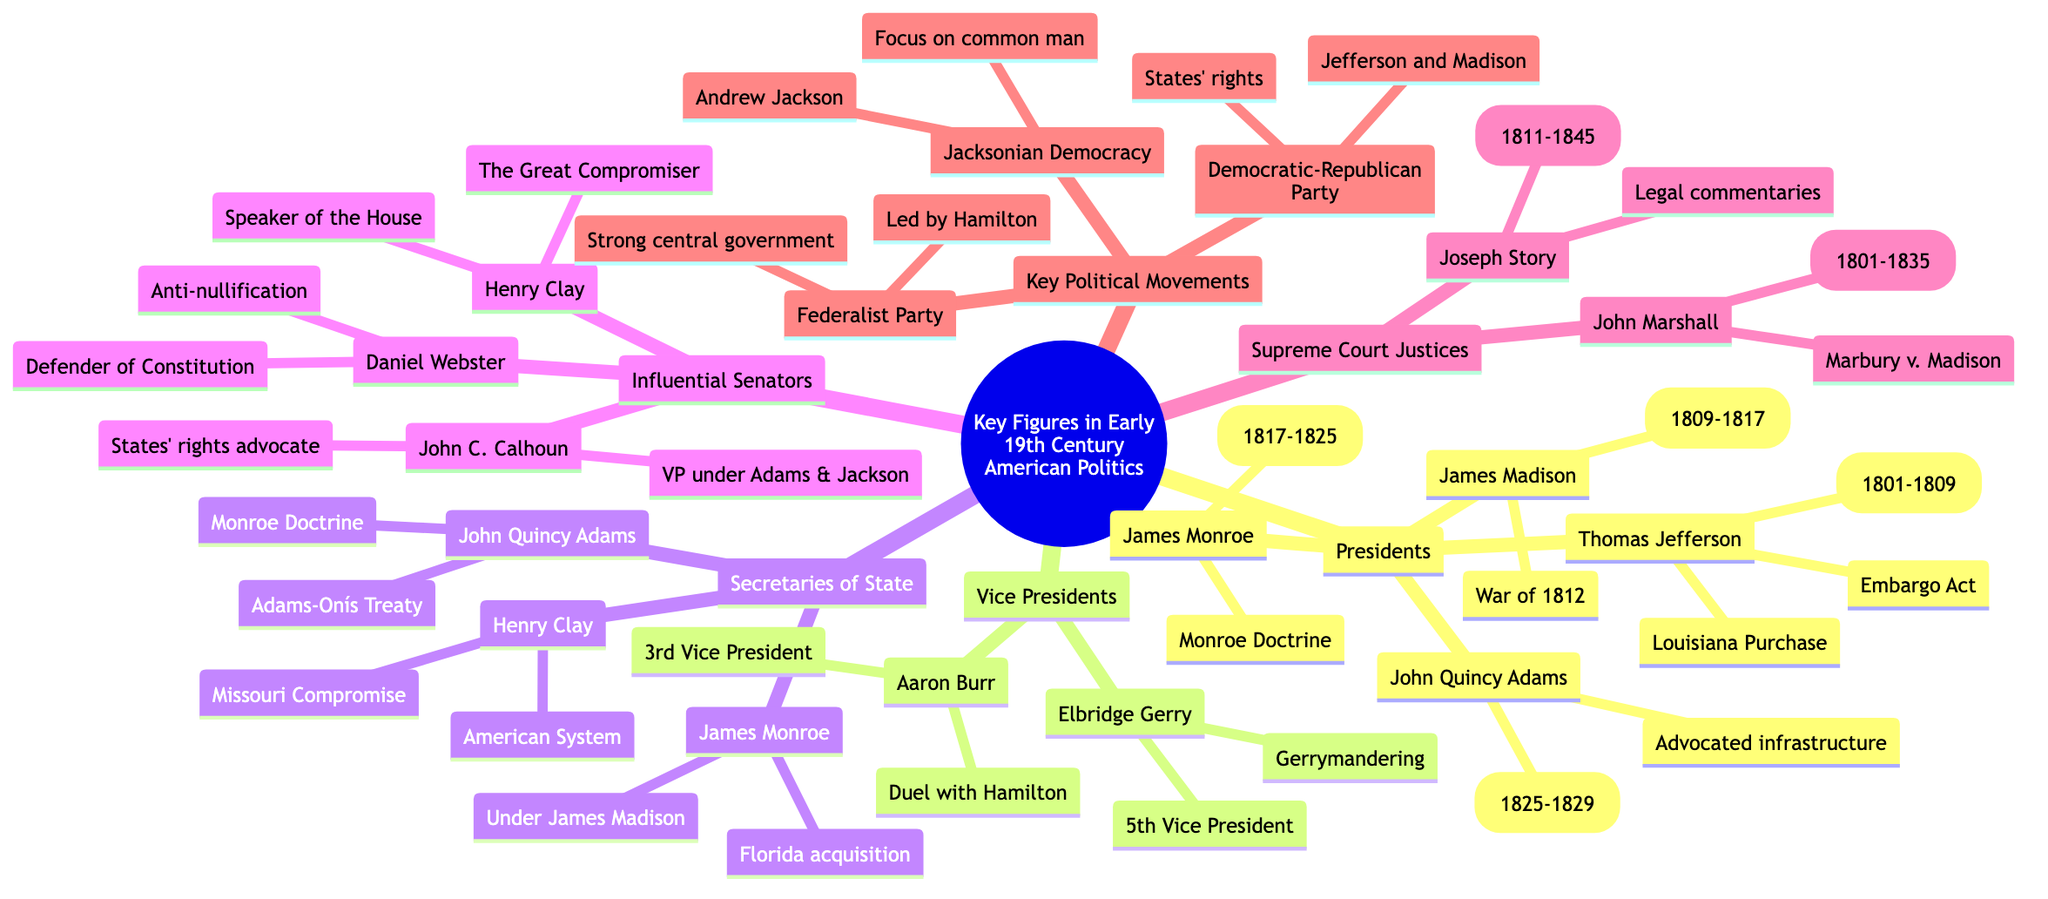What is the 3rd President of the United States? The diagram clearly identifies Thomas Jefferson as the 3rd President and provides his term (1801-1809) under the Presidents subtopic.
Answer: Thomas Jefferson Who was known for the duel with Alexander Hamilton? The diagram lists Aaron Burr under the Vice Presidents subtopic, with a note specifying his fame due to the duel with Hamilton.
Answer: Aaron Burr How many Vice Presidents are mentioned? The diagram lists two Vice Presidents: Aaron Burr and Elbridge Gerry, making a total of 2 under that category.
Answer: 2 What key political movement did Andrew Jackson promote? The Key Political Movements section indicates that Andrew Jackson promoted Jacksonian Democracy, focusing on the common man and being opposed to the national bank.
Answer: Jacksonian Democracy Which Supreme Court Justice established judicial review? The diagram shows John Marshall as the Chief Justice who established judicial review in Marbury v. Madison, under the Supreme Court Justices subtopic.
Answer: John Marshall What was Henry Clay known for in the Senate? The diagram describes Henry Clay as "The Great Compromiser," known for the Missouri Compromise, emphasizing his role in the Senate and notable legislation.
Answer: The Great Compromiser Who settled the Adams-Onís Treaty? The diagram specifies John Quincy Adams under the Secretaries of State subtopic, noting that he settled the Adams-Onís Treaty, indicating his impactful diplomatic work.
Answer: John Quincy Adams Which political party was led by Thomas Jefferson? The diagram indicates that the Democratic-Republican Party was led by Thomas Jefferson and James Madison, under the Key Political Movements section.
Answer: Democratic-Republican Party What was the main focus of the Federalist Party? The diagram explains that the Federalist Party, led by Alexander Hamilton, promoted a strong central government and commercial economy, highlighting its foundational principles.
Answer: Strong central government 